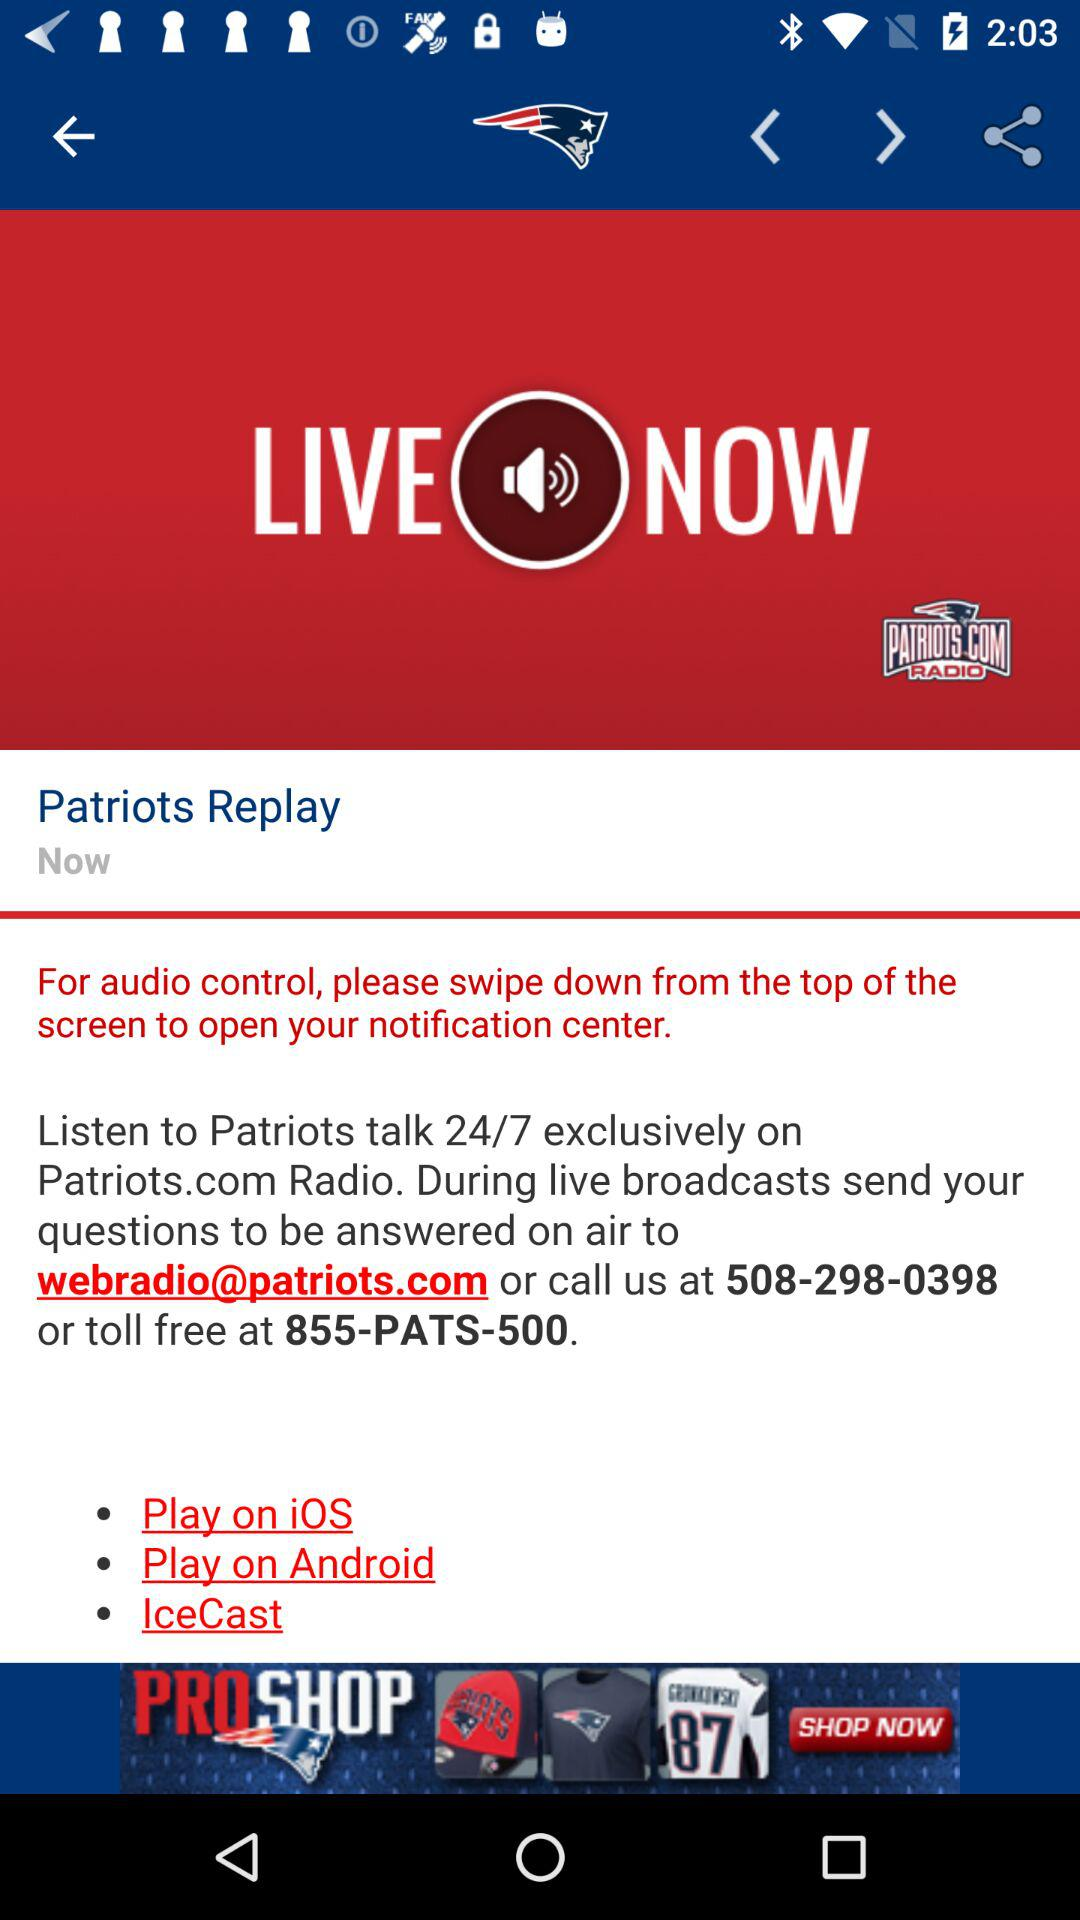When can we listen to "Patriots" talk? You can listen to "Patriots" talk 24/7. 